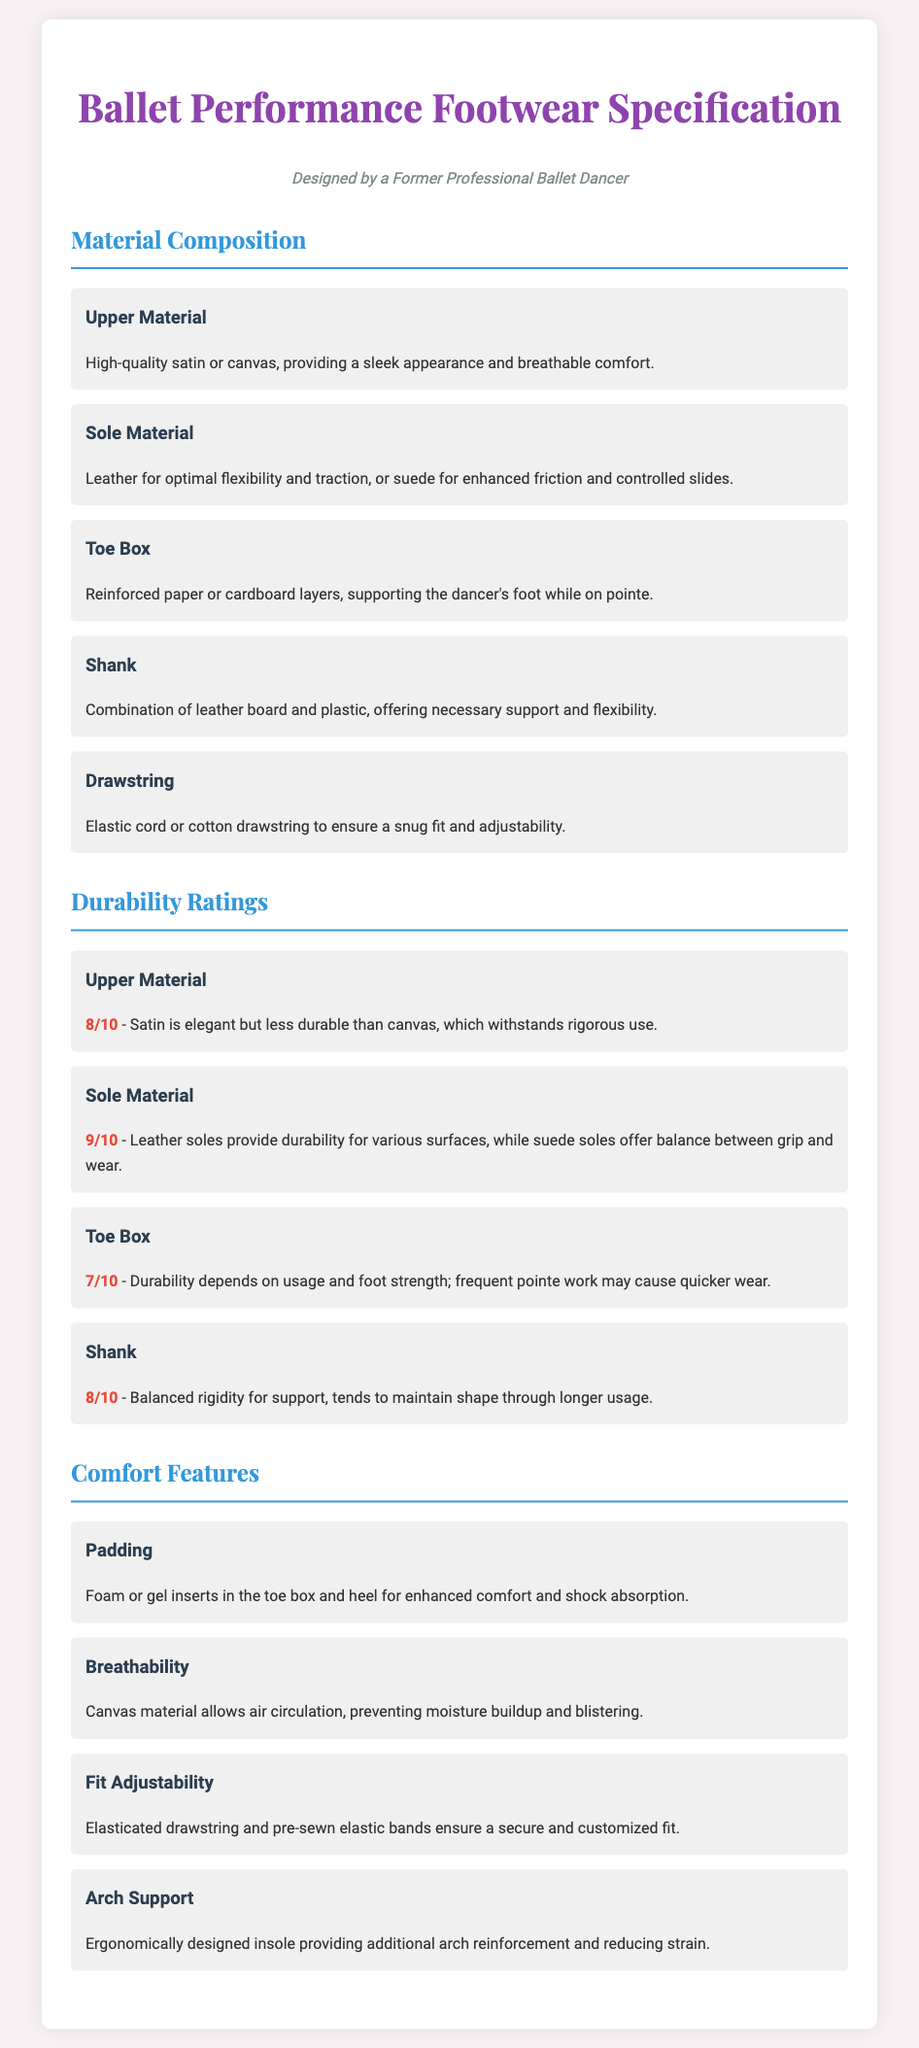what is the upper material of the footwear? The upper material is specified as high-quality satin or canvas.
Answer: satin or canvas what is the durability rating of the sole material? The durability rating for the sole material is provided in the document, which is 9/10.
Answer: 9/10 what type of support does the shank provide? The shank provides a combination of necessary support and flexibility.
Answer: support and flexibility what comfort feature is used for shock absorption? The comfort feature for shock absorption is foam or gel inserts.
Answer: foam or gel inserts what does the toe box support while on pointe? The toe box supports the dancer's foot while on pointe.
Answer: the dancer's foot what ensures a snug fit in the footwear? The document mentions an elastic cord or cotton drawstring that ensures a snug fit.
Answer: elastic cord or cotton drawstring which material offers better durability, satin or canvas? The document indicates that canvas withstands rigorous use better than satin.
Answer: canvas how does the upper material affect breathability? Canvas material allows air circulation, preventing moisture buildup.
Answer: air circulation what is the rating for the toe box's durability? The durability rating for the toe box is mentioned as 7/10.
Answer: 7/10 